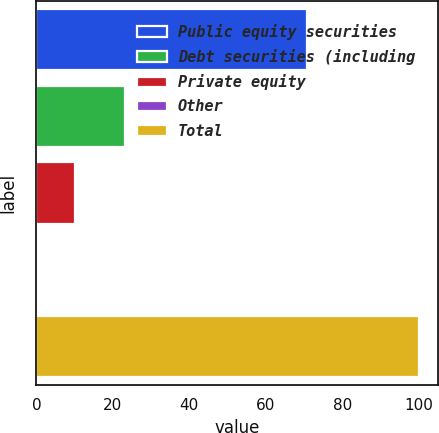<chart> <loc_0><loc_0><loc_500><loc_500><bar_chart><fcel>Public equity securities<fcel>Debt securities (including<fcel>Private equity<fcel>Other<fcel>Total<nl><fcel>70.7<fcel>23.1<fcel>10.18<fcel>0.2<fcel>100<nl></chart> 